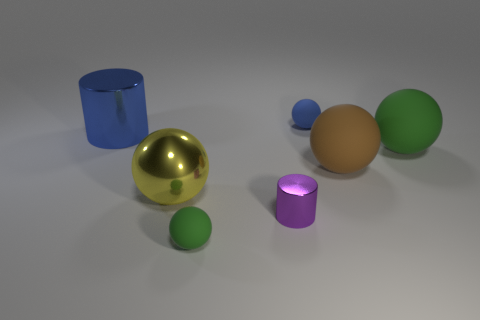The blue object that is the same material as the small cylinder is what shape?
Make the answer very short. Cylinder. Is there anything else that has the same color as the big metallic cylinder?
Keep it short and to the point. Yes. Is the number of blue rubber spheres in front of the brown matte object greater than the number of tiny blue rubber spheres that are in front of the yellow metallic sphere?
Ensure brevity in your answer.  No. How many purple things are the same size as the brown rubber object?
Offer a terse response. 0. Is the number of large blue metallic cylinders on the right side of the tiny purple metallic cylinder less than the number of purple things behind the large cylinder?
Offer a very short reply. No. Is there a blue matte thing of the same shape as the purple metal object?
Ensure brevity in your answer.  No. Does the brown rubber thing have the same shape as the tiny blue object?
Your response must be concise. Yes. How many small things are cyan objects or matte things?
Your answer should be compact. 2. Is the number of big yellow blocks greater than the number of big metal balls?
Your answer should be compact. No. What size is the brown object that is the same material as the small green ball?
Ensure brevity in your answer.  Large. 